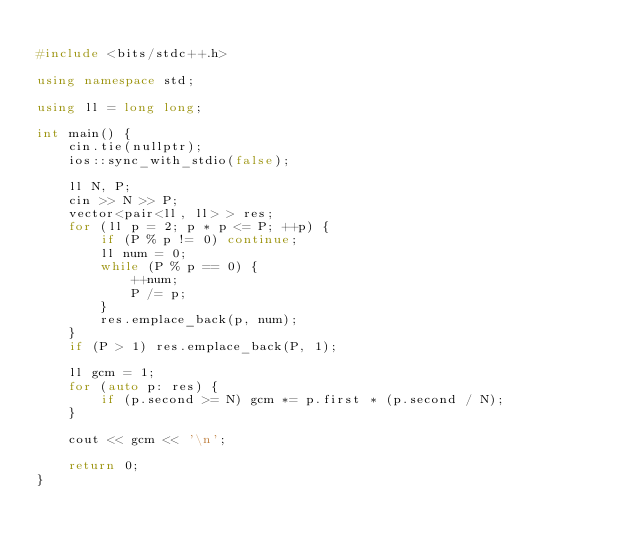<code> <loc_0><loc_0><loc_500><loc_500><_C++_>
#include <bits/stdc++.h>

using namespace std;

using ll = long long; 

int main() {
    cin.tie(nullptr);
    ios::sync_with_stdio(false);

    ll N, P;
    cin >> N >> P;
    vector<pair<ll, ll> > res;
    for (ll p = 2; p * p <= P; ++p) {
        if (P % p != 0) continue;
        ll num = 0;
        while (P % p == 0) {
            ++num;
            P /= p;
        }
        res.emplace_back(p, num);
    }
    if (P > 1) res.emplace_back(P, 1);

    ll gcm = 1;
    for (auto p: res) {
        if (p.second >= N) gcm *= p.first * (p.second / N);
    }

    cout << gcm << '\n';

    return 0;
}
</code> 